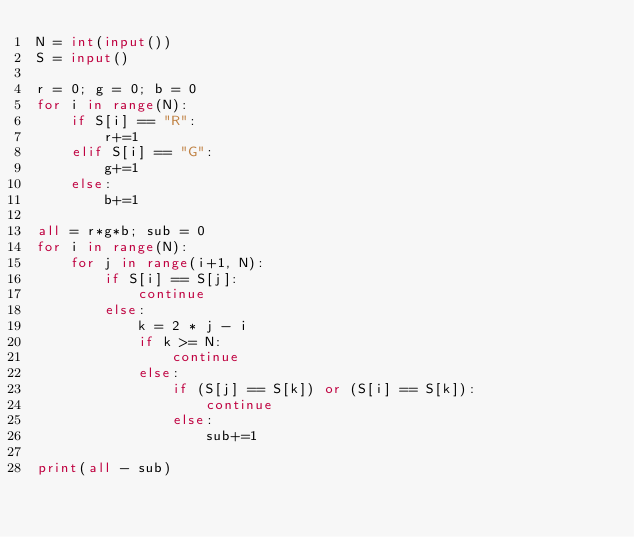Convert code to text. <code><loc_0><loc_0><loc_500><loc_500><_Python_>N = int(input())
S = input()

r = 0; g = 0; b = 0
for i in range(N):
    if S[i] == "R":
        r+=1
    elif S[i] == "G":
        g+=1
    else:
        b+=1

all = r*g*b; sub = 0
for i in range(N):
    for j in range(i+1, N):
        if S[i] == S[j]:
            continue
        else:
            k = 2 * j - i
            if k >= N:
                continue
            else:
                if (S[j] == S[k]) or (S[i] == S[k]):
                    continue
                else:
                    sub+=1

print(all - sub)</code> 